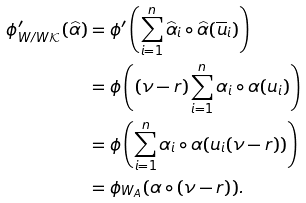<formula> <loc_0><loc_0><loc_500><loc_500>\phi ^ { \prime } _ { W / W \mathcal { K } } ( \widehat { \alpha } ) & = \phi ^ { \prime } \left ( \sum _ { i = 1 } ^ { n } \widehat { \alpha } _ { i } \circ \widehat { \alpha } ( \overline { u } _ { i } ) \right ) \\ & = \phi \left ( ( \nu - r ) \sum _ { i = 1 } ^ { n } \alpha _ { i } \circ \alpha ( u _ { i } ) \right ) \\ & = \phi \left ( \sum _ { i = 1 } ^ { n } \alpha _ { i } \circ \alpha ( u _ { i } ( \nu - r ) ) \right ) \\ & = \phi _ { W _ { A } } ( \alpha \circ ( \nu - r ) ) .</formula> 